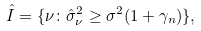<formula> <loc_0><loc_0><loc_500><loc_500>\hat { I } = \{ \nu \colon \hat { \sigma } _ { \nu } ^ { 2 } \geq \sigma ^ { 2 } ( 1 + \gamma _ { n } ) \} ,</formula> 